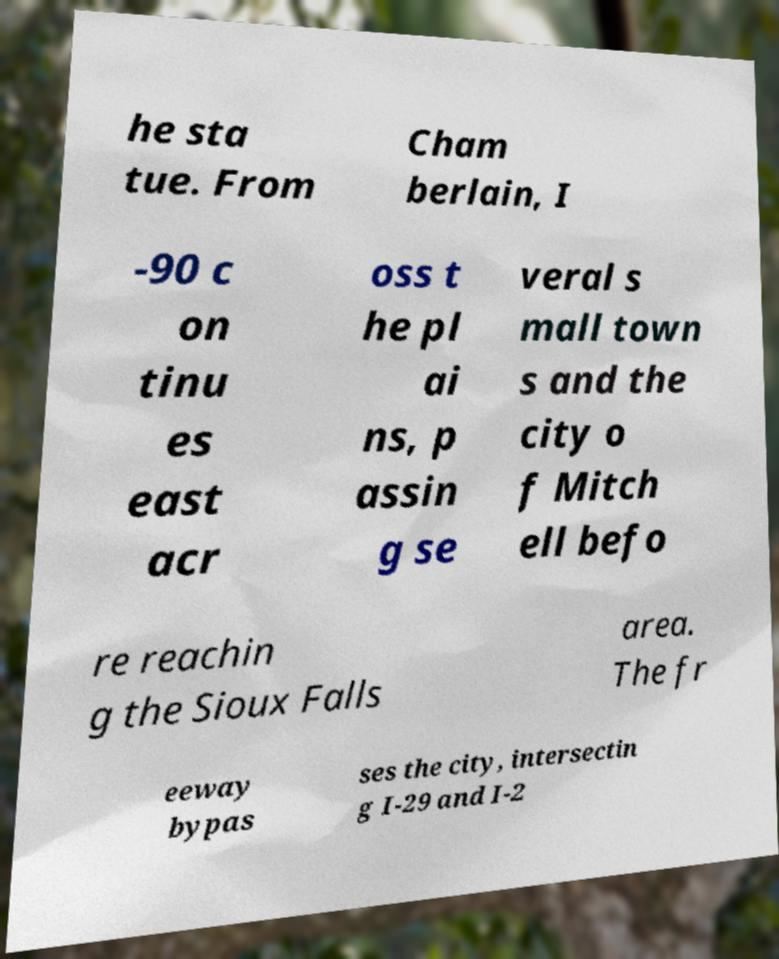Can you read and provide the text displayed in the image?This photo seems to have some interesting text. Can you extract and type it out for me? he sta tue. From Cham berlain, I -90 c on tinu es east acr oss t he pl ai ns, p assin g se veral s mall town s and the city o f Mitch ell befo re reachin g the Sioux Falls area. The fr eeway bypas ses the city, intersectin g I-29 and I-2 